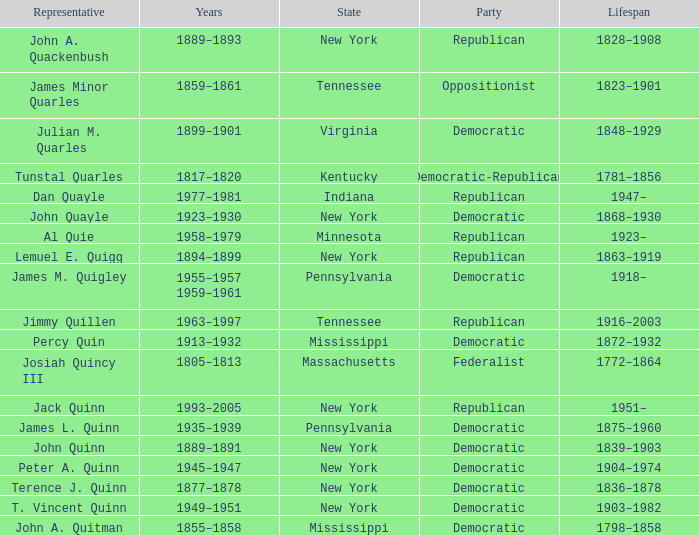What is the lifespan of the democratic party in New York, for which Terence J. Quinn is a representative? 1836–1878. 